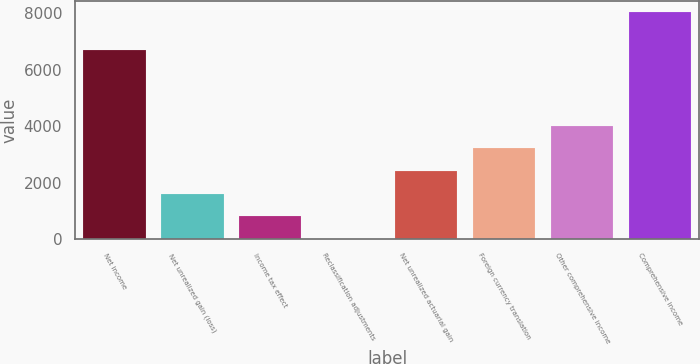Convert chart to OTSL. <chart><loc_0><loc_0><loc_500><loc_500><bar_chart><fcel>Net income<fcel>Net unrealized gain (loss)<fcel>Income tax effect<fcel>Reclassification adjustments<fcel>Net unrealized actuarial gain<fcel>Foreign currency translation<fcel>Other comprehensive income<fcel>Comprehensive income<nl><fcel>6699<fcel>1607.8<fcel>804.4<fcel>1<fcel>2411.2<fcel>3214.6<fcel>4018<fcel>8035<nl></chart> 